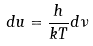Convert formula to latex. <formula><loc_0><loc_0><loc_500><loc_500>d u = \frac { h } { k T } d \nu</formula> 